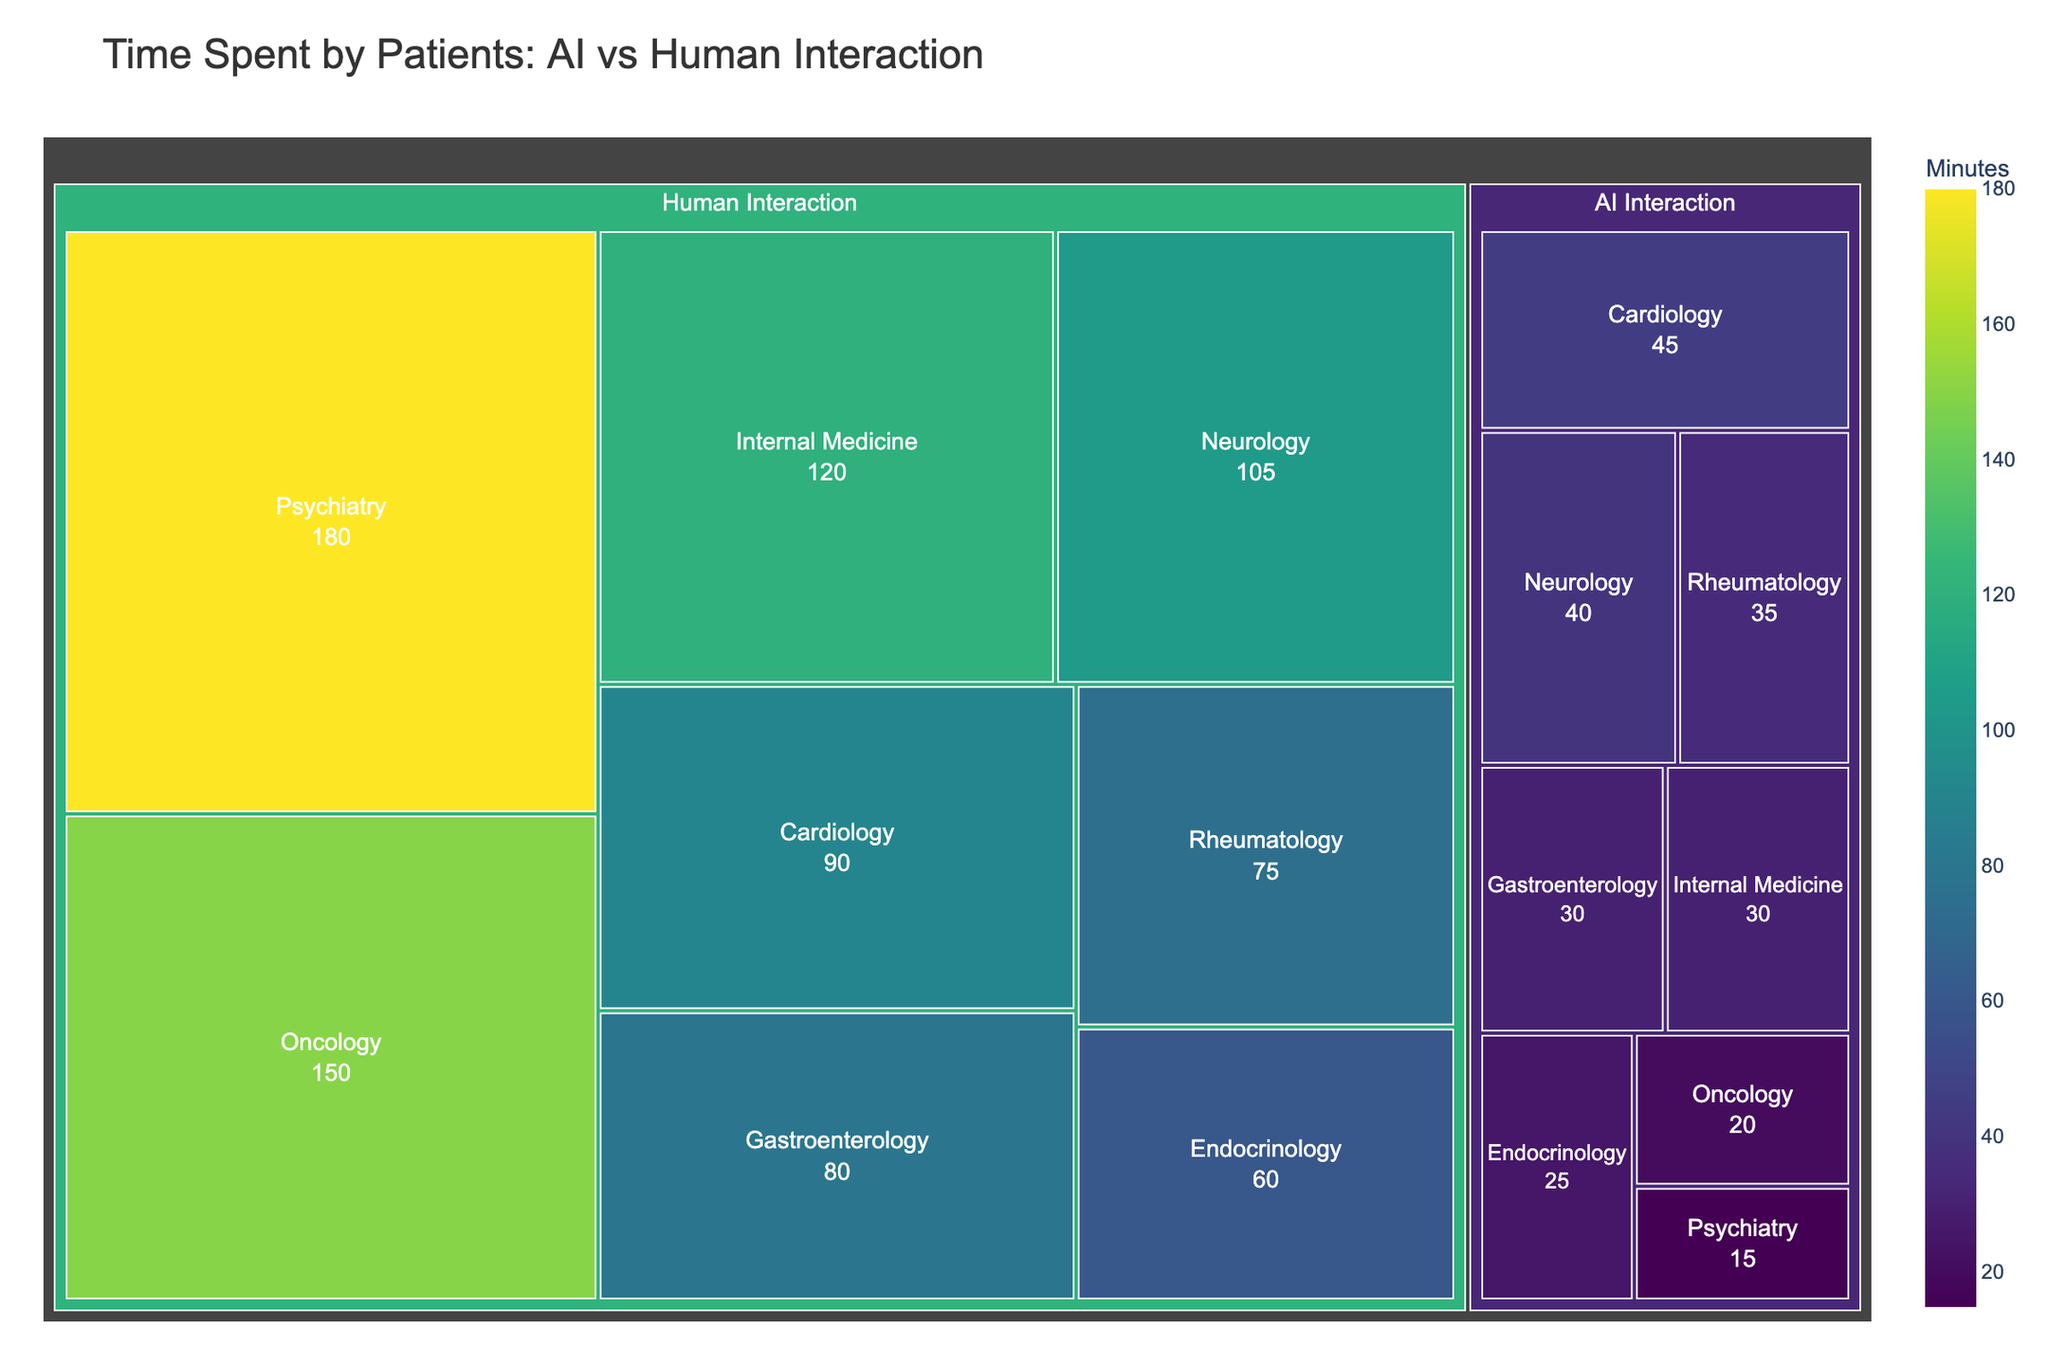What is the title of the figure? The title can be found at the top of the figure. It summarizes the overall content depicted in the treemap.
Answer: Time Spent by Patients: AI vs Human Interaction Which specialty has the most time spent in human interaction? By looking at the section labeled "Human Interaction" and identifying the area representing the most minutes, we can determine the specialty.
Answer: Psychiatry How much time does Cardiology spend on AI interaction? Locate the "Cardiology" section under "AI Interaction" and note the value shown in minutes.
Answer: 45 minutes What is the total time spent on human interactions across all specialties? Sum the values of minutes for all specialties under "Human Interaction": 120 + 90 + 150 + 105 + 180 + 75 + 60 + 80
Answer: 860 minutes How does the time spent on AI interaction compare between Neurology and Gastroenterology? Find the minutes spent on AI Interaction for Neurology and Gastroenterology, then compare the two values (40 minutes for Neurology and 30 minutes for Gastroenterology).
Answer: Neurology has more time spent on AI interaction than Gastroenterology What is the smallest time spent on AI interaction among all specialties? Identify the smallest value under the "AI Interaction" category by examining all the specialty sections.
Answer: 15 minutes (Psychiatry) Which specialty category has a larger time spent: Oncology (Human Interaction) or Cardiology (Human Interaction)? Compare the time in minutes of Oncology under Human Interaction (150) with that of Cardiology (90).
Answer: Oncology What is the proportion of time spent on AI interaction to human interaction in Internal Medicine? Divide the AI interaction time in Internal Medicine (30) by the human interaction time (120) and multiply by 100 to get the percentage. 30/120 * 100 = 25%
Answer: 25% Which category generally shows larger blocks: Human Interaction or AI Interaction? By observing the areas of the sections labeled "Human Interaction" and "AI Interaction," we can see which category has larger blocks overall.
Answer: Human Interaction What is the average time spent on AI interaction across all specialties? Sum the AI Interaction minutes for all specialties and divide by the number of specialties: (30 + 45 + 20 + 40 + 15 + 35 + 25 + 30)/8 = 30.
Answer: 30 minutes 